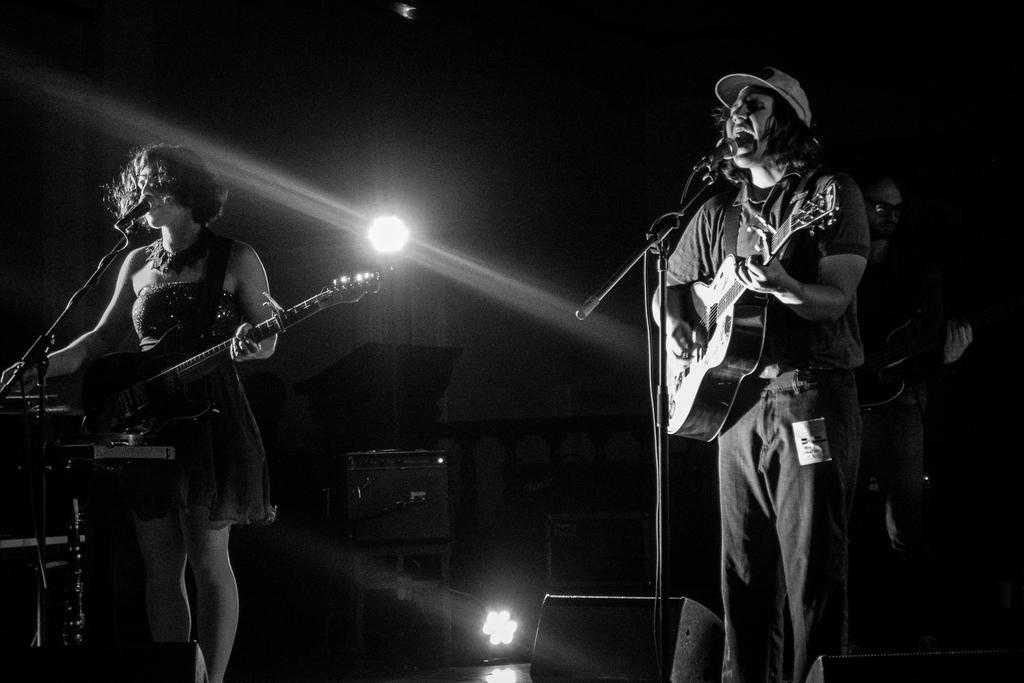Can you describe this image briefly? This picture shows a men and a woman singing with the help of a microphone and playing guitar and we see other man standing and playing guitar on the back 